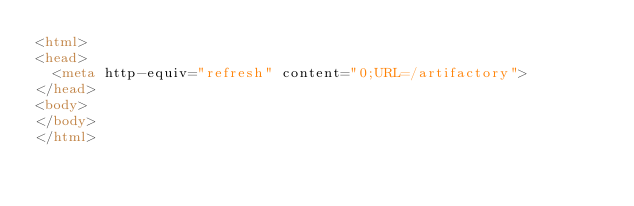<code> <loc_0><loc_0><loc_500><loc_500><_HTML_><html>
<head>
	<meta http-equiv="refresh" content="0;URL=/artifactory">
</head>
<body>
</body>
</html>
</code> 